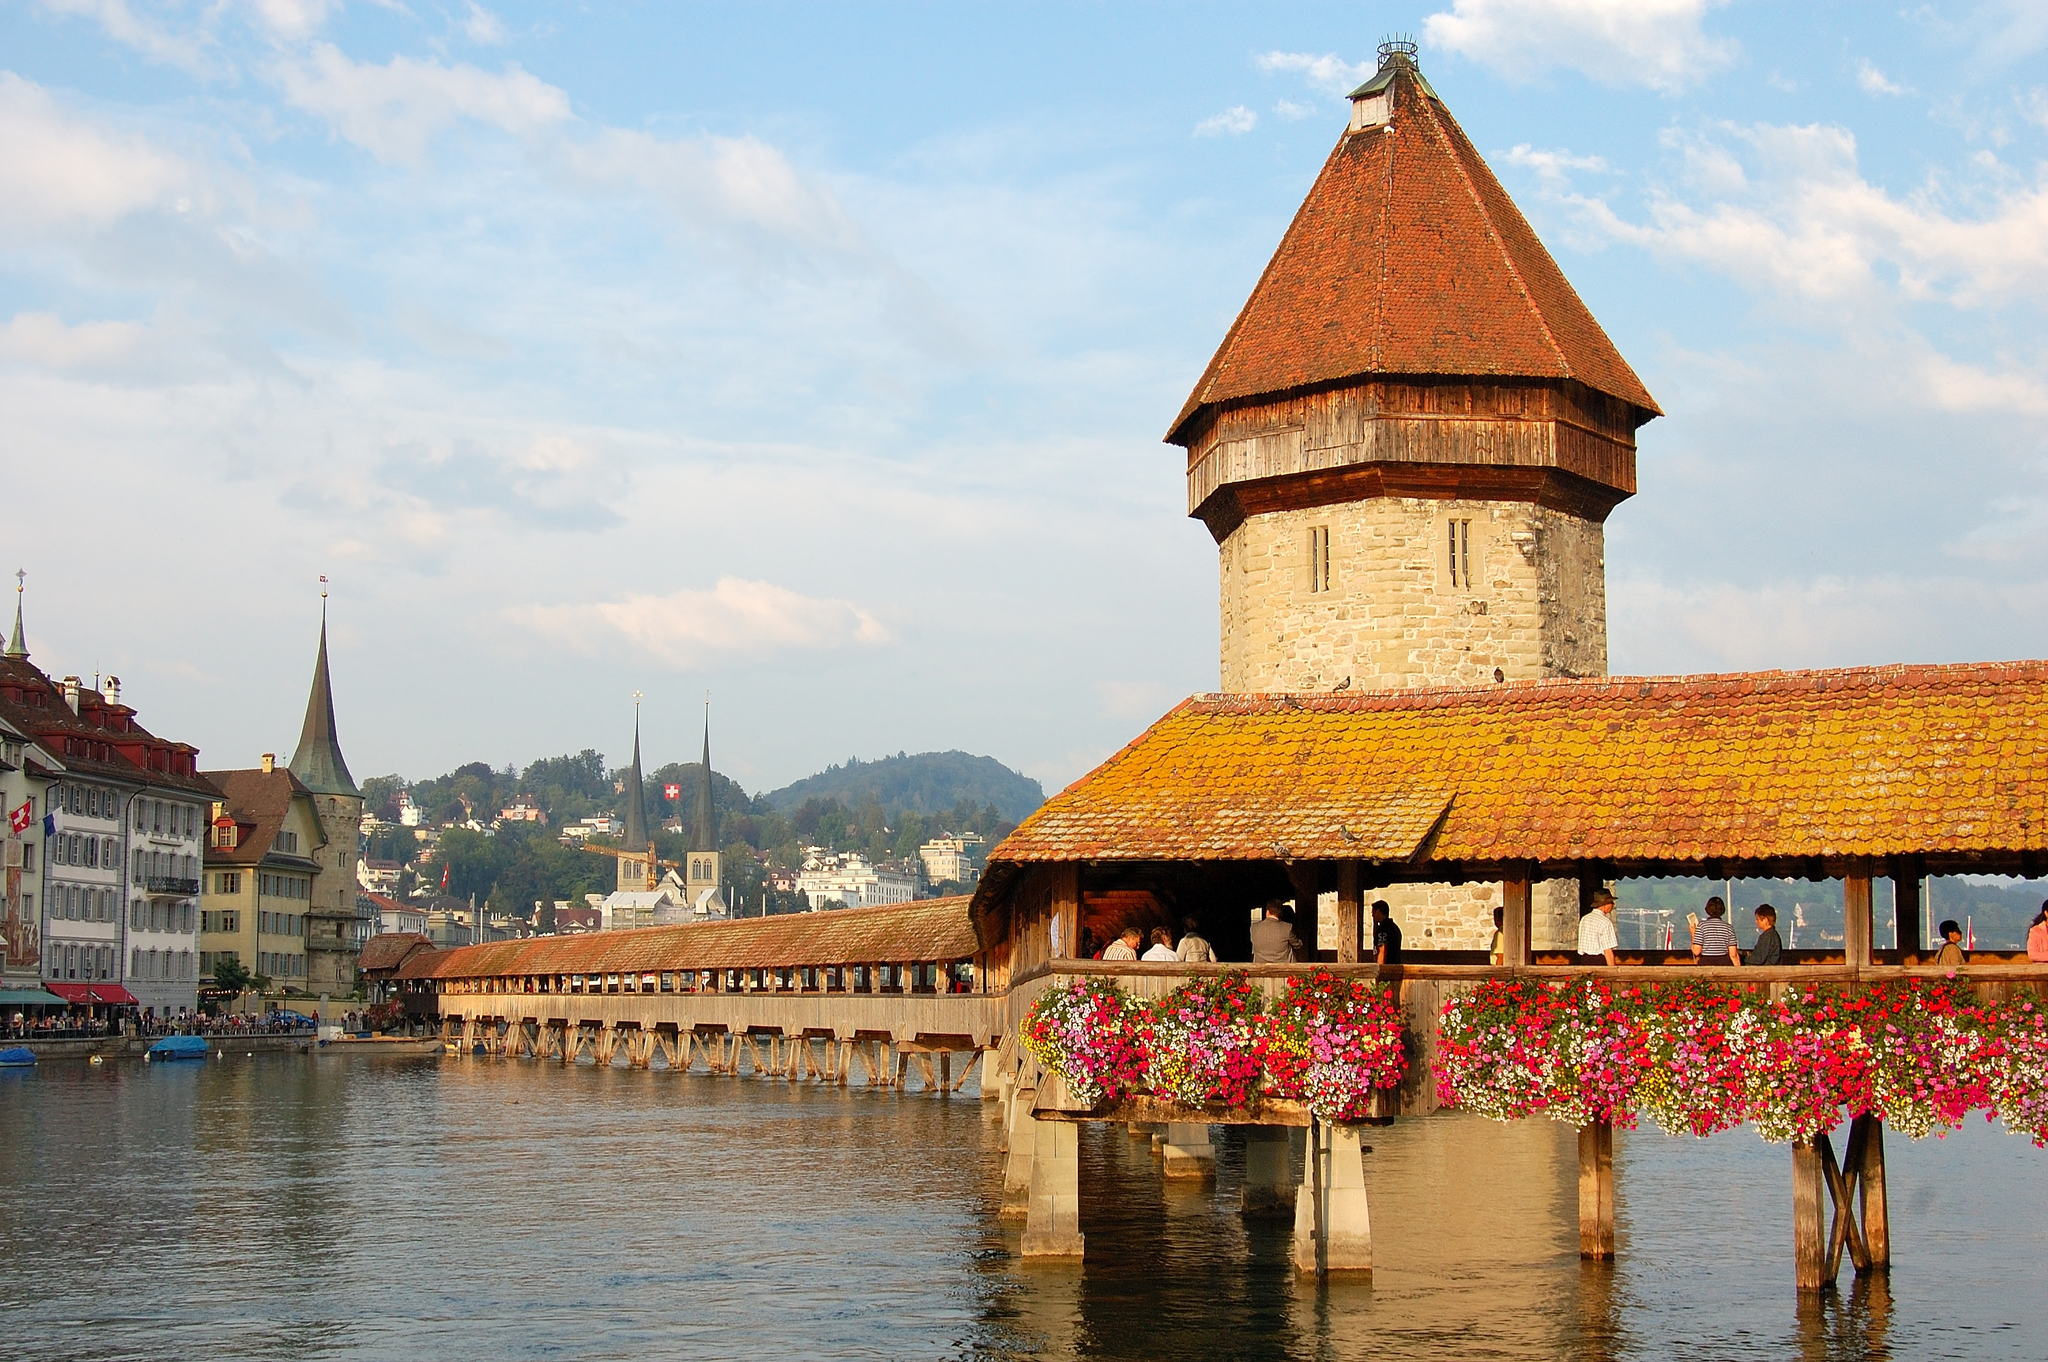Imagine if this bridge could tell stories, what might it say about its history? If Chapel Bridge could tell its own stories, it would speak of centuries of resilience and transformation. Starting with its construction in 1333 as a defensive structure, witnessing the Black Death sweep through Europe, the rise and fall of empires, and the day-to-day lives of merchants and citizens in medieval Lucerne. It would recount the devastating fire in 1993 that nearly destroyed it but also the city's determination to restore it to its former glory. Its tales would be of the countless romantic walks, the festive parades, and the quiet, reflective moments of individuals captivated by its timeless charm. If the flowers on the bridge could speak, what poetry might they recite about the seasons? The flowers adorning Chapel Bridge might recite poetry filled with the joys and changes of the seasons. 'In Spring’s tender embrace, we bloom anew, vibrant colors paint the old and true. Summer’s warmth, we bask in golden light, a bridge adorned, a truly splendid sight. Autumn whispers with winds crisp and cool, dancing leaves echo a tranquil pool. Winter comes, we sleep beneath nature’s white, dreaming of days when we again take flight.' 